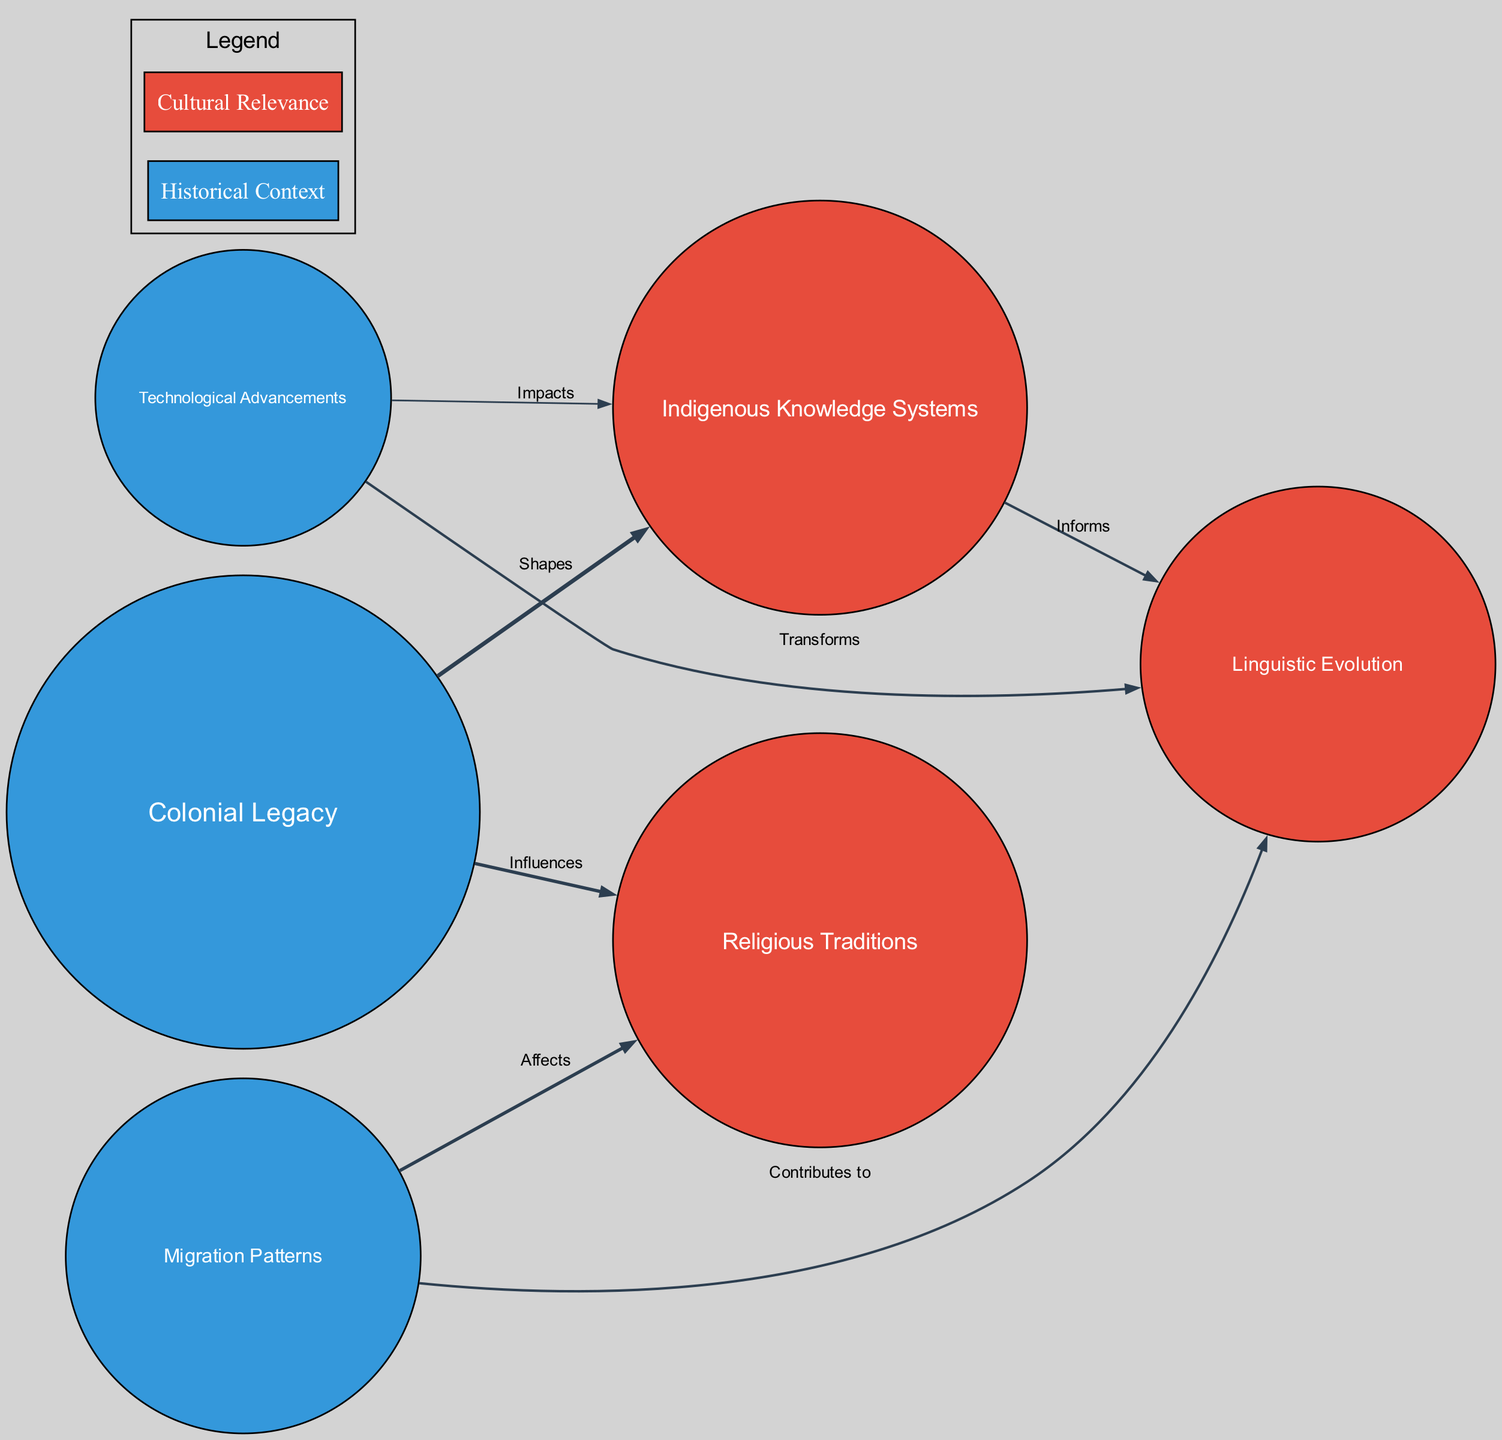What is the size of the "Colonial Legacy" node? The size of the "Colonial Legacy" node is given in the data as 40. This is a direct read of the attributes associated with the node labeled "Colonial Legacy."
Answer: 40 How many nodes are in the diagram? By counting the number of entries in the "nodes" section of the data, we find that there are 6 nodes total.
Answer: 6 What edge connects "Indigenous Knowledge Systems" and "Linguistic Evolution"? The edge that connects these two nodes is described in the data. It states that the connection is labeled "Informs" with a value of 3. This indicates a relationship between these two topics.
Answer: Informs What is the total weight of the edges coming from "Migration Patterns"? The edges originating from "Migration Patterns" include those to "Religious Traditions" (value 4) and to "Linguistic Evolution" (value 3). Summing these values gives 4 + 3 = 7, which is the total weight of the edges from this node.
Answer: 7 Which node has the highest size? By comparing the sizes of all nodes listed in the data, we find that "Colonial Legacy" has the highest size value of 40. This is the highest among all other sizes.
Answer: Colonial Legacy How many relationships does "Technological Advancements" have? There are two edges originating from "Technological Advancements": one to "Indigenous Knowledge Systems" (value 2) and the other to "Linguistic Evolution" (value 3). Therefore, it has a total of 2 relationships.
Answer: 2 Which node is influenced by the "Colonial Legacy"? The nodes that are influenced by "Colonial Legacy" according to the edges are "Indigenous Knowledge Systems" (labeled "Shapes") and "Religious Traditions" (labeled "Influences"). Thus, the answer refers to both nodes.
Answer: Indigenous Knowledge Systems, Religious Traditions What is the relationship strength between "Migration Patterns" and "Religious Traditions"? The edge between "Migration Patterns" and "Religious Traditions" has a value of 4 assigned to it, indicating a strong relationship. This value is associated with the label "Affects."
Answer: 4 Which group has more nodes: Historical Context or Cultural Relevance? By counting the nodes in each group, Historical Context has 3 nodes ("Colonial Legacy," "Migration Patterns," "Technological Advancements"), while Cultural Relevance has 3 nodes ("Indigenous Knowledge Systems," "Religious Traditions," "Linguistic Evolution"). Thus, they are equal in number.
Answer: Equal 